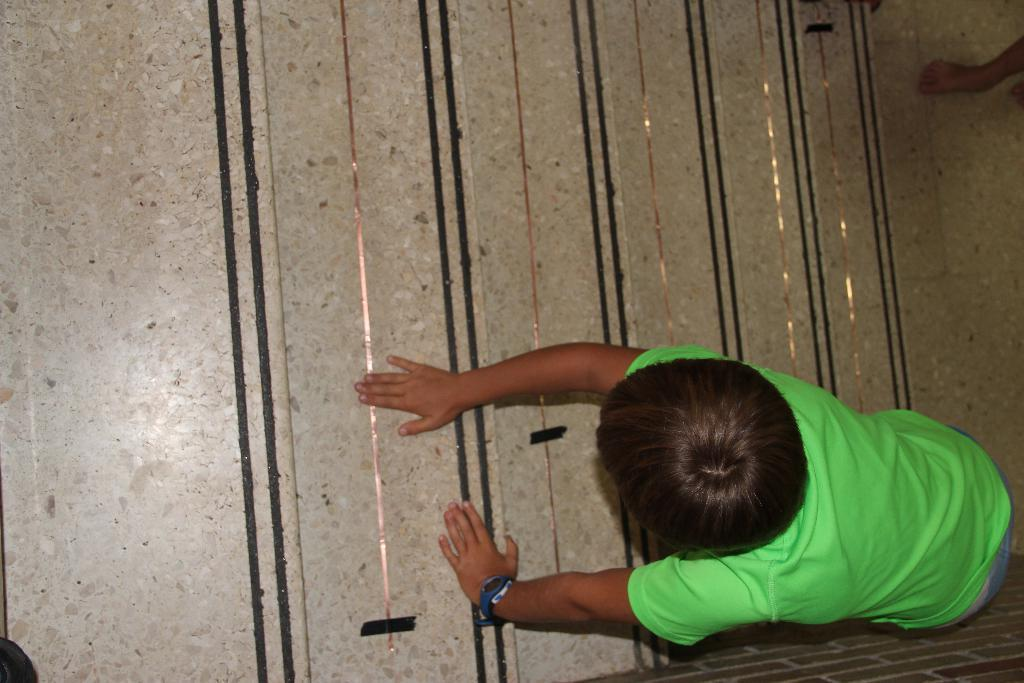What is the main subject of the image? The main subject of the image is a kid. How is the kid positioned in the image? The kid has one hand on the ground and the other hand on an object. Can you describe any other elements in the image? There is a leg of a person in the right top corner of the image. What type of plot is visible in the image? There is no plot visible in the image; it features a kid in a specific position. Can you tell me how many mint leaves are present in the image? There are no mint leaves present in the image. 